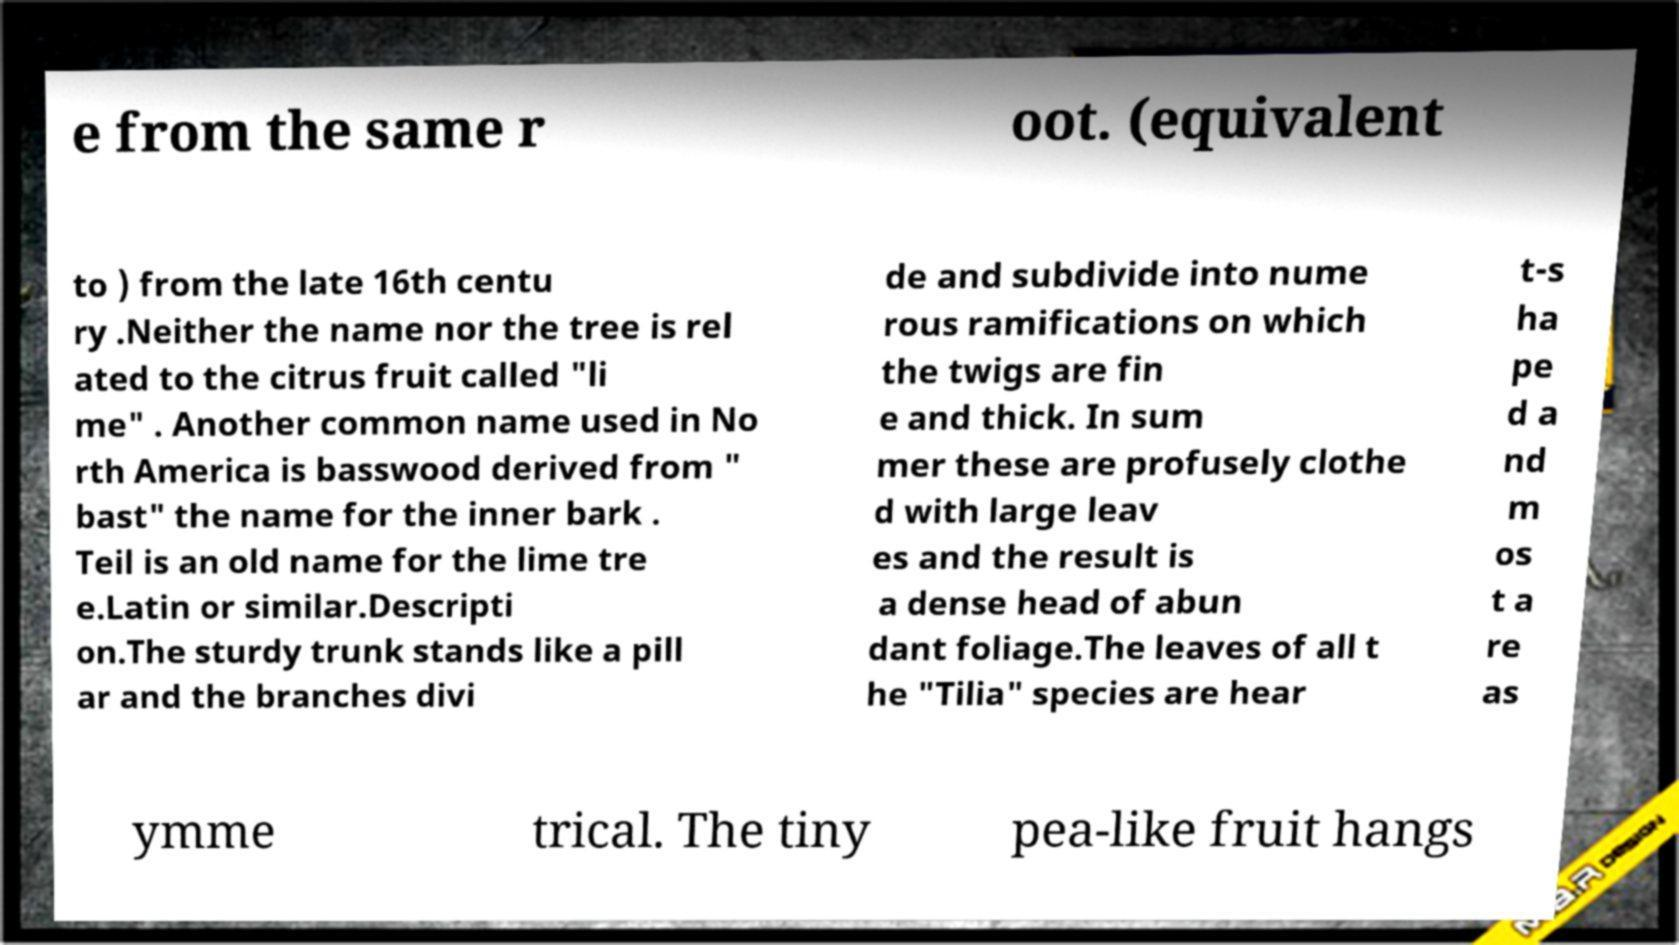Please identify and transcribe the text found in this image. e from the same r oot. (equivalent to ) from the late 16th centu ry .Neither the name nor the tree is rel ated to the citrus fruit called "li me" . Another common name used in No rth America is basswood derived from " bast" the name for the inner bark . Teil is an old name for the lime tre e.Latin or similar.Descripti on.The sturdy trunk stands like a pill ar and the branches divi de and subdivide into nume rous ramifications on which the twigs are fin e and thick. In sum mer these are profusely clothe d with large leav es and the result is a dense head of abun dant foliage.The leaves of all t he "Tilia" species are hear t-s ha pe d a nd m os t a re as ymme trical. The tiny pea-like fruit hangs 